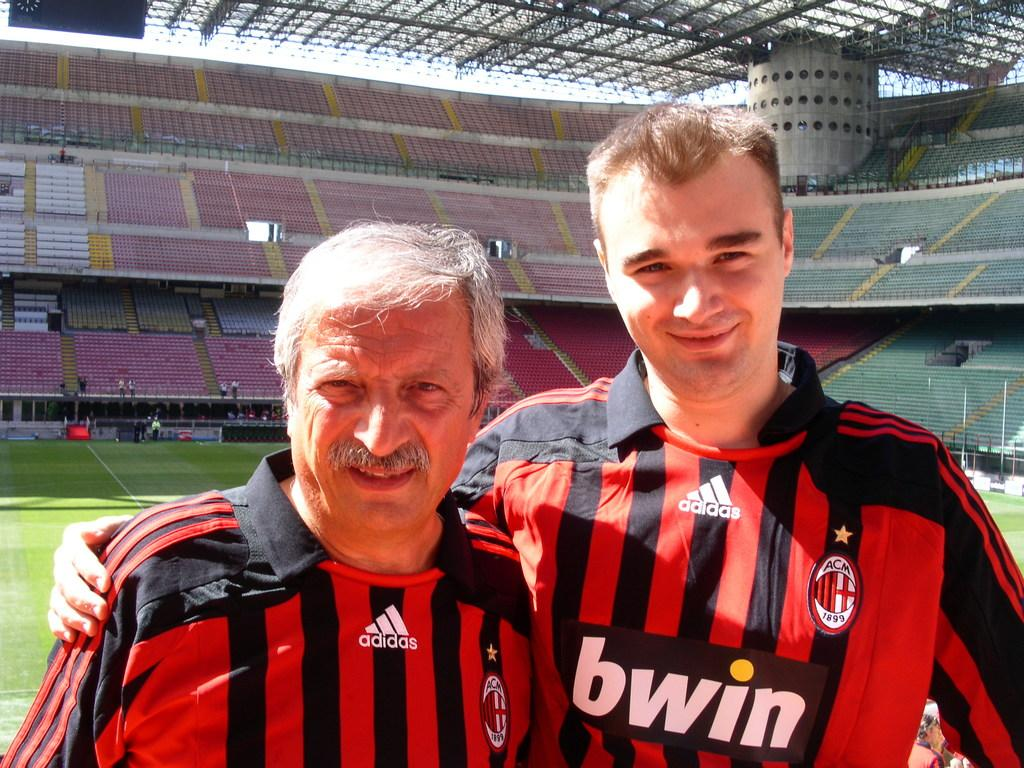Provide a one-sentence caption for the provided image. Two members of the bwin team pose next to each other. 